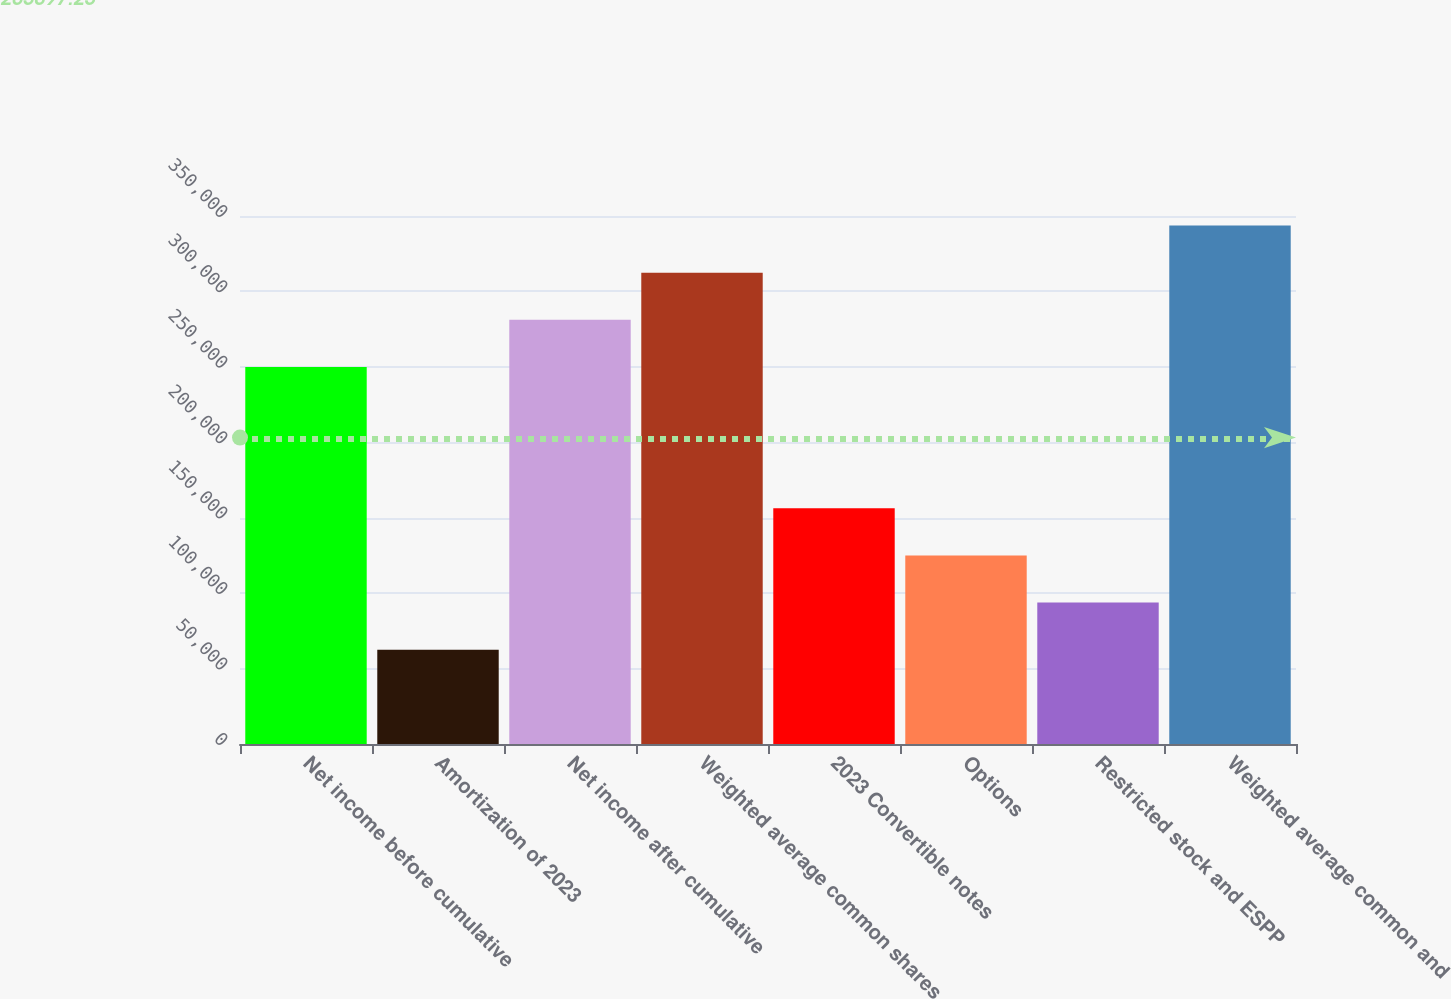Convert chart. <chart><loc_0><loc_0><loc_500><loc_500><bar_chart><fcel>Net income before cumulative<fcel>Amortization of 2023<fcel>Net income after cumulative<fcel>Weighted average common shares<fcel>2023 Convertible notes<fcel>Options<fcel>Restricted stock and ESPP<fcel>Weighted average common and<nl><fcel>249966<fcel>62491.8<fcel>281211<fcel>312457<fcel>156229<fcel>124983<fcel>93737.5<fcel>343703<nl></chart> 